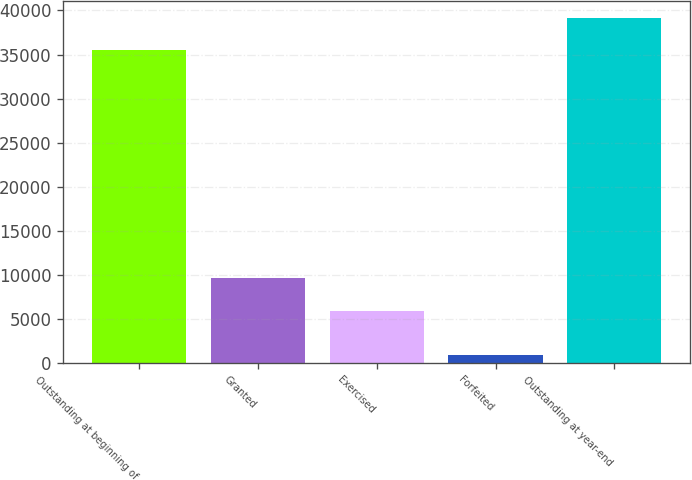Convert chart. <chart><loc_0><loc_0><loc_500><loc_500><bar_chart><fcel>Outstanding at beginning of<fcel>Granted<fcel>Exercised<fcel>Forfeited<fcel>Outstanding at year-end<nl><fcel>35500<fcel>9621.6<fcel>5962<fcel>903<fcel>39159.6<nl></chart> 